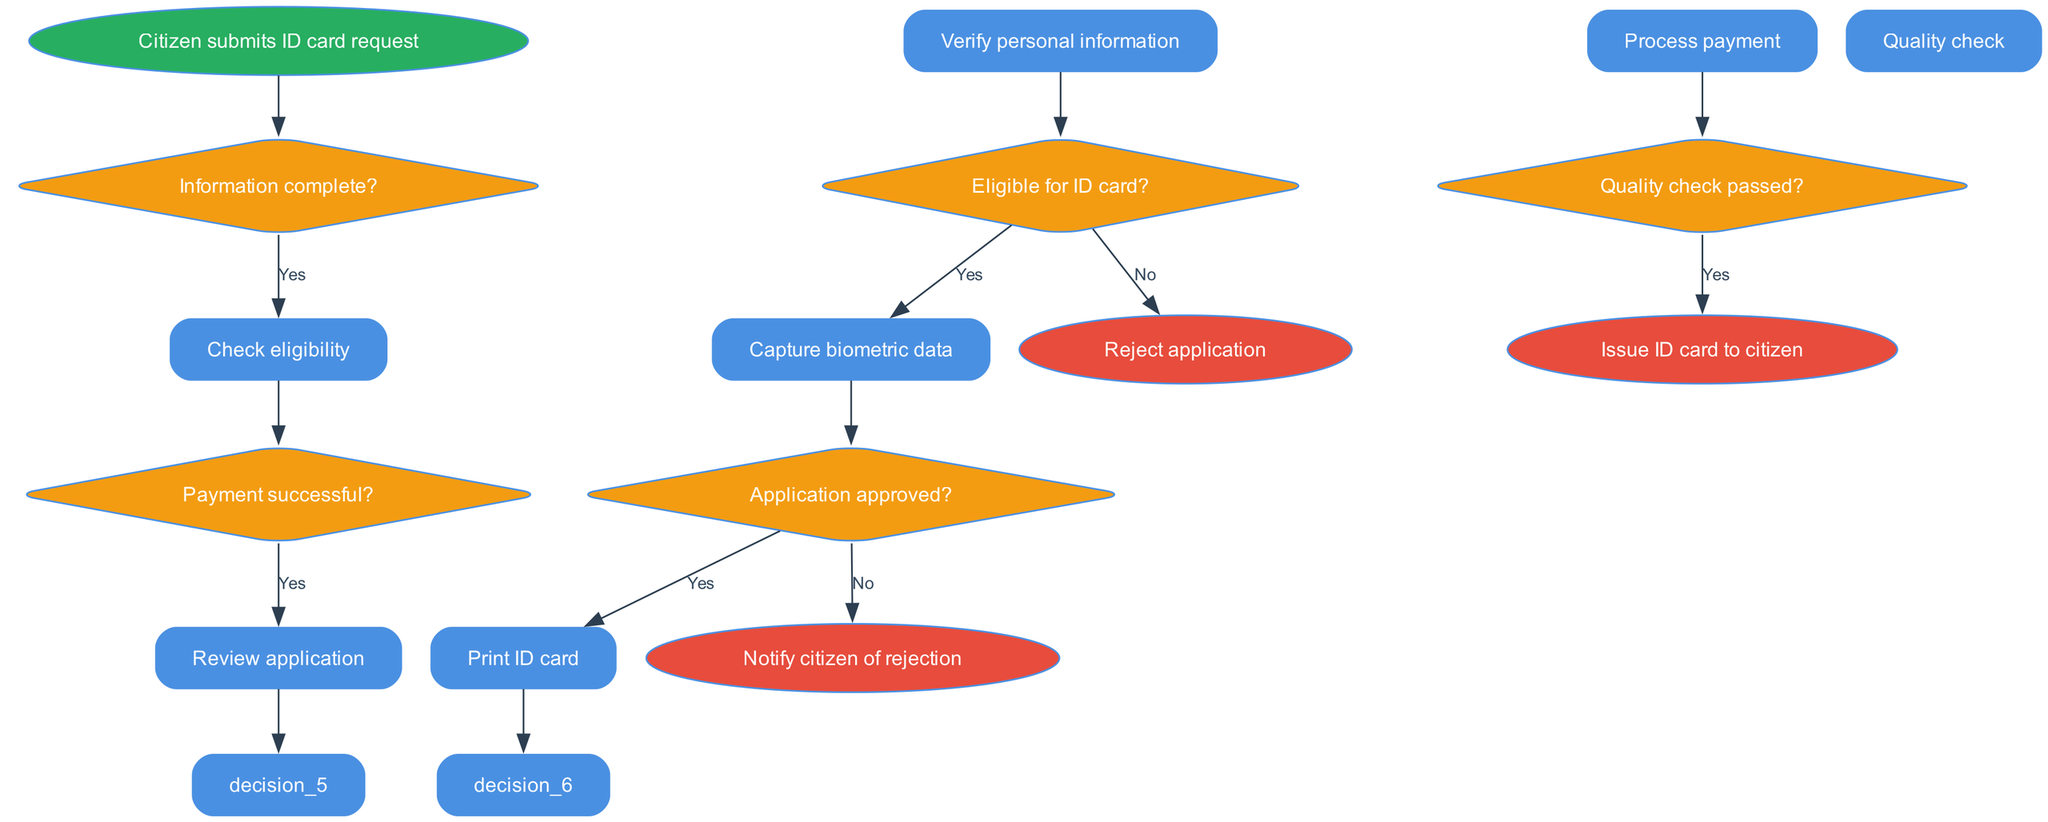What is the starting point of the process? The starting point, as indicated in the diagram, is the node labeled "Citizen submits ID card request". This is the first action to begin the process flow.
Answer: Citizen submits ID card request How many decision nodes are there? The diagram contains a total of five decision nodes, each associated with different conditions that affect the flow of the process.
Answer: 5 What happens if the personal information is incomplete? If the personal information is incomplete, the flow shows that the process returns to the citizen for completion, as indicated by the "no" path from the first decision node.
Answer: Return to citizen for completion What is required after the eligibility check? After verifying eligibility, the process continues to capture biometric data, as shown by the "yes" path leading to the next process node.
Answer: Capture biometric data What action is taken if the payment is unsuccessful? If the payment is unsuccessful, the flow diagram directs to request an alternative payment, indicated by the "no" path after the payment decision node.
Answer: Request alternative payment What is the final decision point in the process? The final decision point is regarding the quality check; if it passes, the ID card is issued, and if not, it indicates to reprint the ID card. This is shown as the last decision node before the end of the process.
Answer: Quality check passed? What occurs if the application is rejected? If the application is rejected, the flow indicates that the citizen is notified of this rejection, following the "no" path from the application approval decision node.
Answer: Notify citizen of rejection How many processes are involved in the function? The function comprises a total of six processes through which the citizen's request is processed, as listed in the diagram.
Answer: 6 What is issued to the citizen at the end of the process? At the end of the process, the output is the issuance of an ID card to the citizen, as confirmed at the end node labeled "Issue ID card to citizen".
Answer: Issue ID card to citizen 